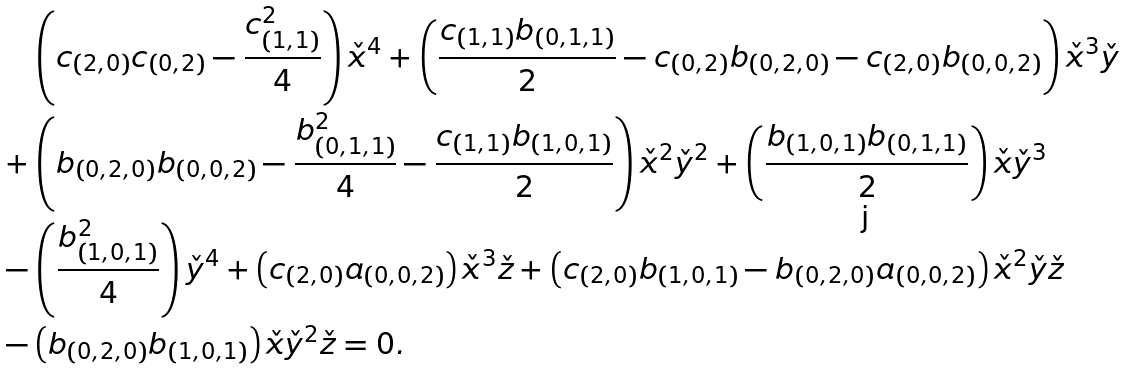<formula> <loc_0><loc_0><loc_500><loc_500>& \left ( c _ { ( 2 , 0 ) } c _ { ( 0 , 2 ) } - \frac { c _ { ( 1 , 1 ) } ^ { 2 } } { 4 } \right ) \check { x } ^ { 4 } + \left ( \frac { c _ { ( 1 , 1 ) } b _ { ( 0 , 1 , 1 ) } } { 2 } - c _ { ( 0 , 2 ) } b _ { ( 0 , 2 , 0 ) } - c _ { ( 2 , 0 ) } b _ { ( 0 , 0 , 2 ) } \right ) \check { x } ^ { 3 } \check { y } \\ + & \left ( b _ { ( 0 , 2 , 0 ) } b _ { ( 0 , 0 , 2 ) } - \frac { b _ { ( 0 , 1 , 1 ) } ^ { 2 } } { 4 } - \frac { c _ { ( 1 , 1 ) } b _ { ( 1 , 0 , 1 ) } } { 2 } \right ) \check { x } ^ { 2 } \check { y } ^ { 2 } + \left ( \frac { b _ { ( 1 , 0 , 1 ) } b _ { ( 0 , 1 , 1 ) } } { 2 } \right ) \check { x } \check { y } ^ { 3 } \\ - & \left ( \frac { b _ { ( 1 , 0 , 1 ) } ^ { 2 } } { 4 } \right ) \check { y } ^ { 4 } + \left ( c _ { ( 2 , 0 ) } a _ { ( 0 , 0 , 2 ) } \right ) \check { x } ^ { 3 } \check { z } + \left ( c _ { ( 2 , 0 ) } b _ { ( 1 , 0 , 1 ) } - b _ { ( 0 , 2 , 0 ) } a _ { ( 0 , 0 , 2 ) } \right ) \check { x } ^ { 2 } \check { y } \check { z } \\ - & \left ( b _ { ( 0 , 2 , 0 ) } b _ { ( 1 , 0 , 1 ) } \right ) \check { x } \check { y } ^ { 2 } \check { z } = 0 .</formula> 